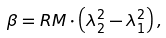Convert formula to latex. <formula><loc_0><loc_0><loc_500><loc_500>\beta = R M \cdot \left ( \lambda _ { 2 } ^ { 2 } - \lambda _ { 1 } ^ { 2 } \right ) ,</formula> 